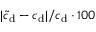Convert formula to latex. <formula><loc_0><loc_0><loc_500><loc_500>| \tilde { c } _ { d } - c _ { d } | / c _ { d } \cdot 1 0 0 \</formula> 